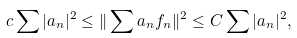Convert formula to latex. <formula><loc_0><loc_0><loc_500><loc_500>c \sum | a _ { n } | ^ { 2 } \leq \| \sum a _ { n } f _ { n } \| ^ { 2 } \leq C \sum | a _ { n } | ^ { 2 } ,</formula> 